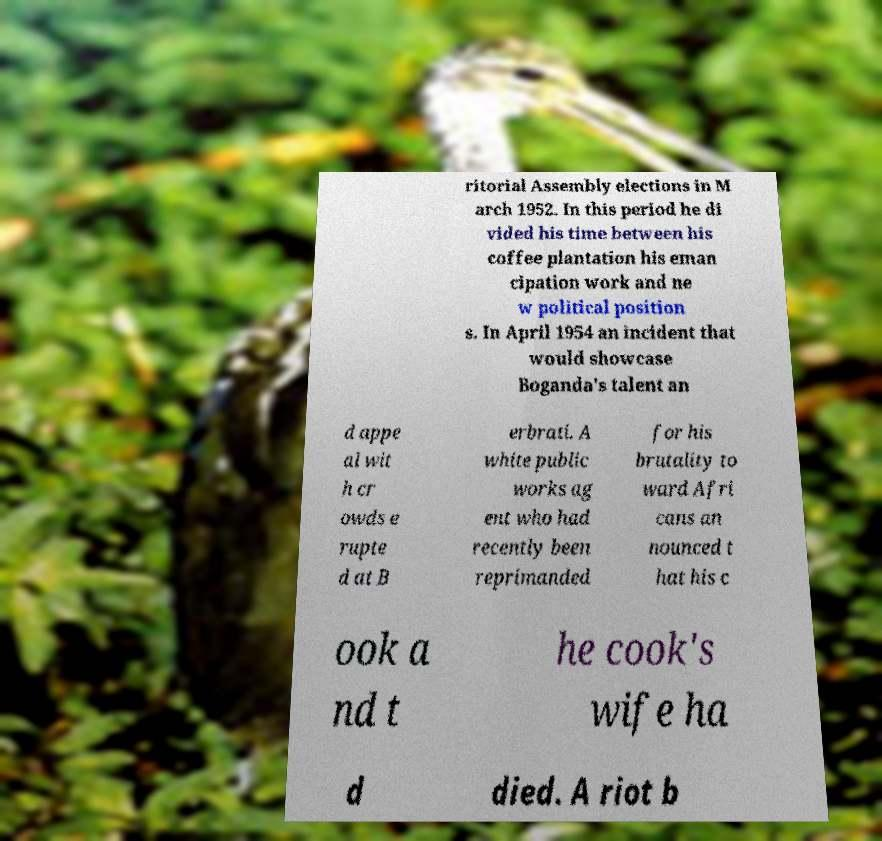What messages or text are displayed in this image? I need them in a readable, typed format. ritorial Assembly elections in M arch 1952. In this period he di vided his time between his coffee plantation his eman cipation work and ne w political position s. In April 1954 an incident that would showcase Boganda's talent an d appe al wit h cr owds e rupte d at B erbrati. A white public works ag ent who had recently been reprimanded for his brutality to ward Afri cans an nounced t hat his c ook a nd t he cook's wife ha d died. A riot b 